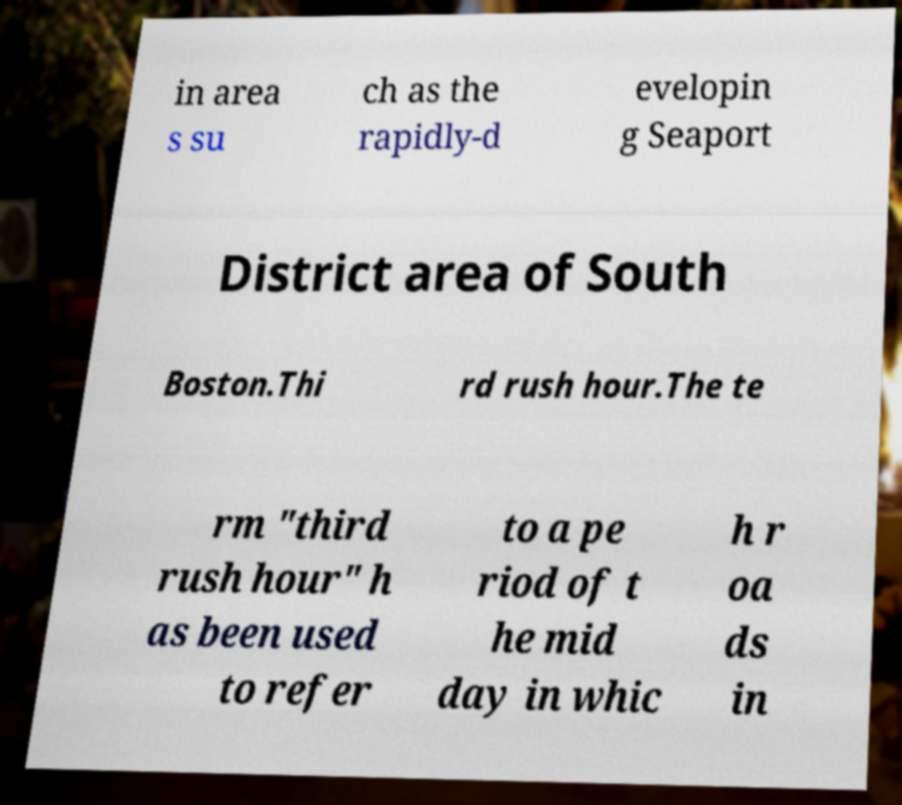Can you read and provide the text displayed in the image?This photo seems to have some interesting text. Can you extract and type it out for me? in area s su ch as the rapidly-d evelopin g Seaport District area of South Boston.Thi rd rush hour.The te rm "third rush hour" h as been used to refer to a pe riod of t he mid day in whic h r oa ds in 